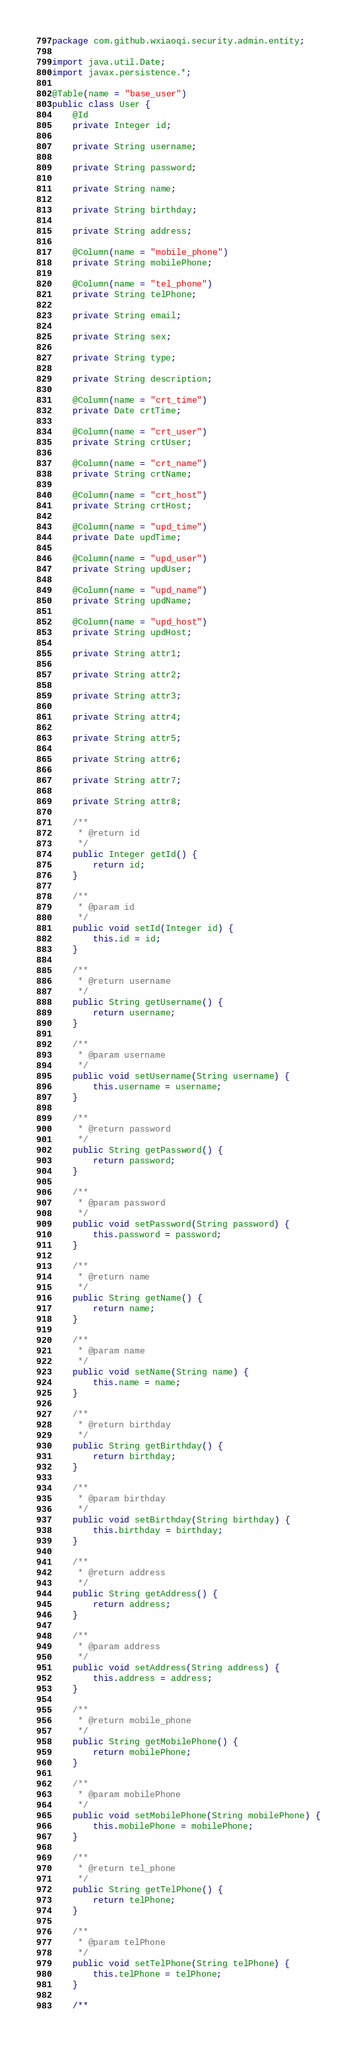Convert code to text. <code><loc_0><loc_0><loc_500><loc_500><_Java_>package com.github.wxiaoqi.security.admin.entity;

import java.util.Date;
import javax.persistence.*;

@Table(name = "base_user")
public class User {
    @Id
    private Integer id;

    private String username;

    private String password;

    private String name;

    private String birthday;

    private String address;

    @Column(name = "mobile_phone")
    private String mobilePhone;

    @Column(name = "tel_phone")
    private String telPhone;

    private String email;

    private String sex;

    private String type;

    private String description;

    @Column(name = "crt_time")
    private Date crtTime;

    @Column(name = "crt_user")
    private String crtUser;

    @Column(name = "crt_name")
    private String crtName;

    @Column(name = "crt_host")
    private String crtHost;

    @Column(name = "upd_time")
    private Date updTime;

    @Column(name = "upd_user")
    private String updUser;

    @Column(name = "upd_name")
    private String updName;

    @Column(name = "upd_host")
    private String updHost;

    private String attr1;

    private String attr2;

    private String attr3;

    private String attr4;

    private String attr5;

    private String attr6;

    private String attr7;

    private String attr8;

    /**
     * @return id
     */
    public Integer getId() {
        return id;
    }

    /**
     * @param id
     */
    public void setId(Integer id) {
        this.id = id;
    }

    /**
     * @return username
     */
    public String getUsername() {
        return username;
    }

    /**
     * @param username
     */
    public void setUsername(String username) {
        this.username = username;
    }

    /**
     * @return password
     */
    public String getPassword() {
        return password;
    }

    /**
     * @param password
     */
    public void setPassword(String password) {
        this.password = password;
    }

    /**
     * @return name
     */
    public String getName() {
        return name;
    }

    /**
     * @param name
     */
    public void setName(String name) {
        this.name = name;
    }

    /**
     * @return birthday
     */
    public String getBirthday() {
        return birthday;
    }

    /**
     * @param birthday
     */
    public void setBirthday(String birthday) {
        this.birthday = birthday;
    }

    /**
     * @return address
     */
    public String getAddress() {
        return address;
    }

    /**
     * @param address
     */
    public void setAddress(String address) {
        this.address = address;
    }

    /**
     * @return mobile_phone
     */
    public String getMobilePhone() {
        return mobilePhone;
    }

    /**
     * @param mobilePhone
     */
    public void setMobilePhone(String mobilePhone) {
        this.mobilePhone = mobilePhone;
    }

    /**
     * @return tel_phone
     */
    public String getTelPhone() {
        return telPhone;
    }

    /**
     * @param telPhone
     */
    public void setTelPhone(String telPhone) {
        this.telPhone = telPhone;
    }

    /**</code> 